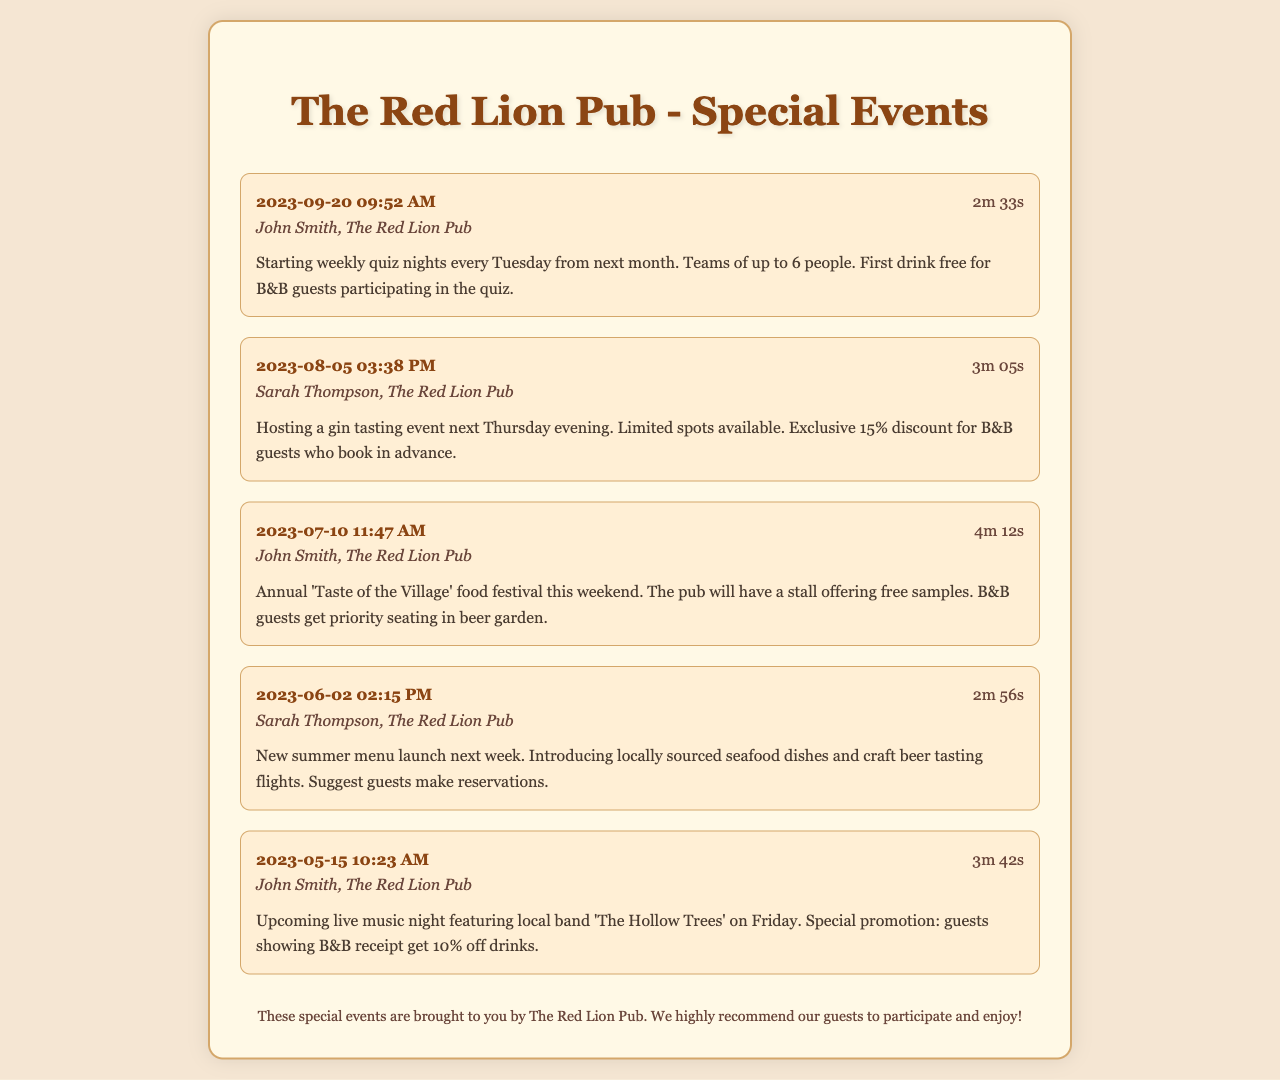What day are the quiz nights starting? The quiz nights are starting every Tuesday from next month, as mentioned in the summary of the call.
Answer: Tuesday Who called about the gin tasting event? The caller regarding the gin tasting event is Sarah Thompson, as indicated in the call record.
Answer: Sarah Thompson What is the special offer for B&B guests at the quiz night? The special offer for B&B guests participating in the quiz is a free first drink, highlighted in the call summary.
Answer: First drink free When is the annual 'Taste of the Village' food festival? The food festival is taking place this weekend, as noted in the relevant record's summary.
Answer: This weekend What discount do B&B guests receive for the gin tasting event? The exclusive discount for B&B guests who book in advance for the gin tasting event is 15%, as stated in the summary.
Answer: 15% What event is happening on Friday? The event that is taking place on Friday is a live music night featuring 'The Hollow Trees.'
Answer: Live music night What should guests do for the new summer menu launch? Guests are suggested to make reservations for the new summer menu launch, as indicated in the call from Sarah Thompson.
Answer: Make reservations Who gets priority seating at the food festival? B&B guests receive priority seating in the beer garden during the food festival, based on the summary provided.
Answer: B&B guests How long was the call about the live music night? The duration of the call discussing the live music night was 3 minutes and 42 seconds, as listed in the call record.
Answer: 3m 42s 